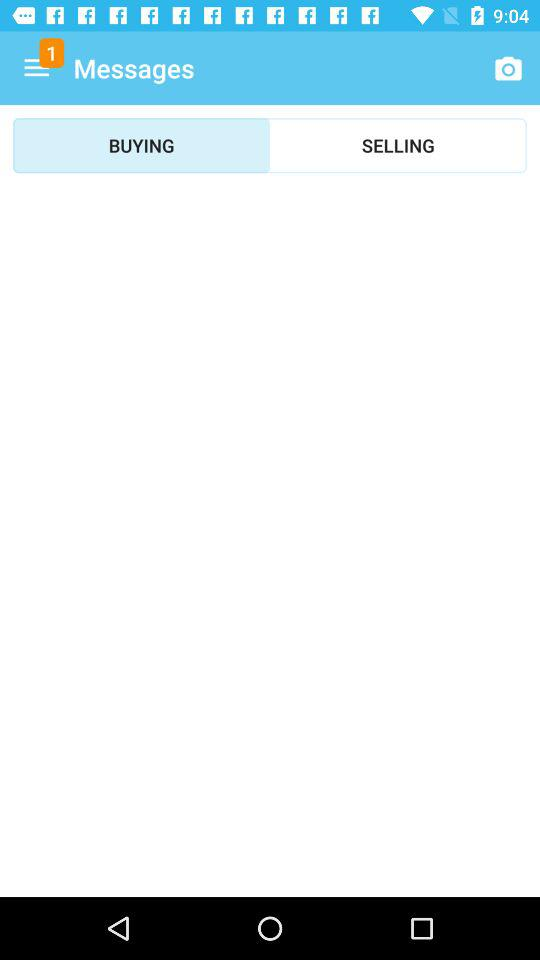What tab is selected? The selected tab is "BUYING". 